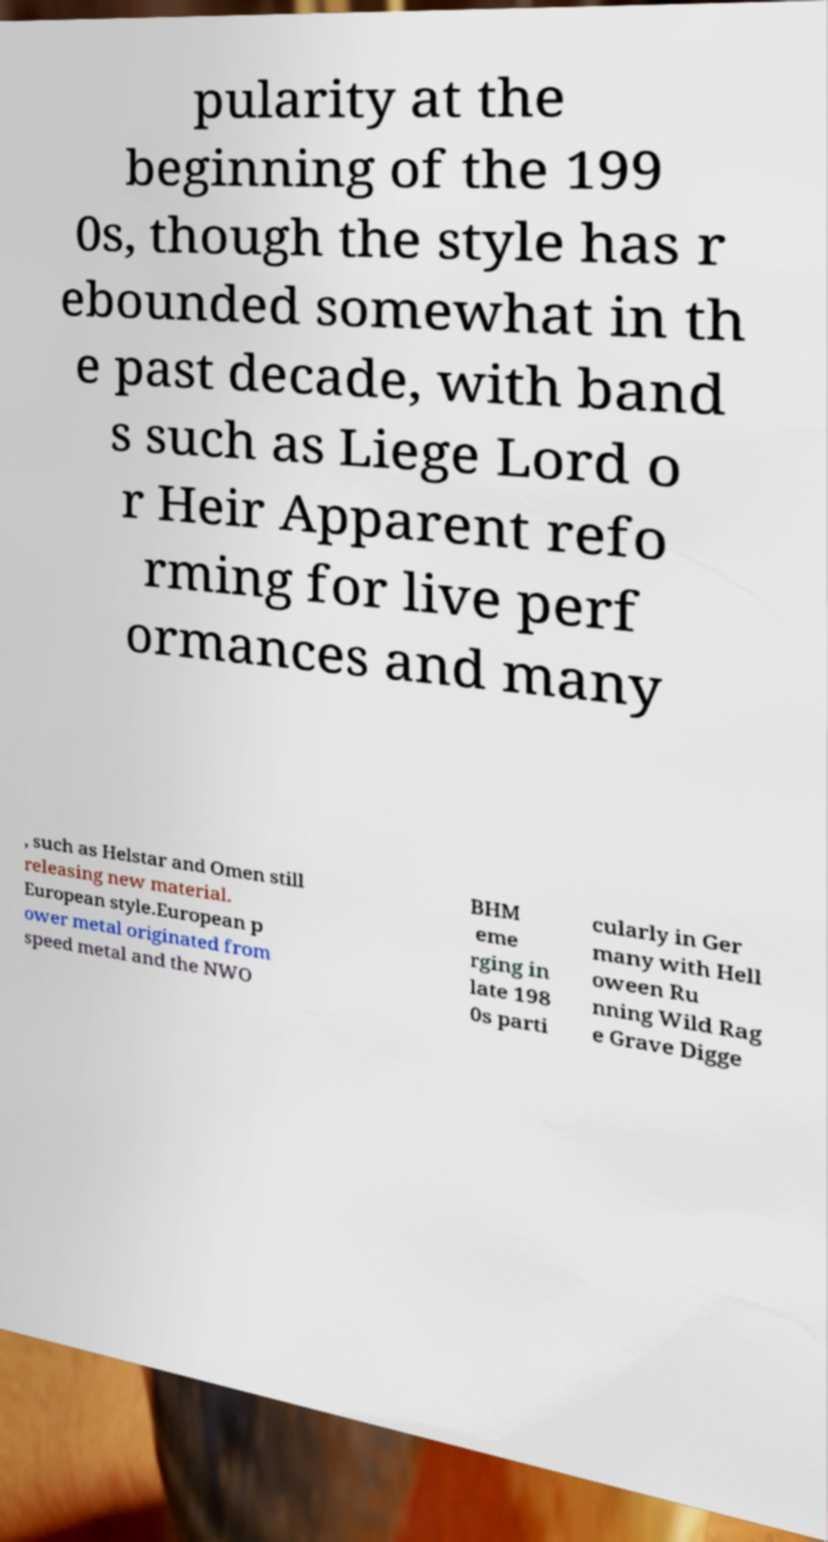Could you assist in decoding the text presented in this image and type it out clearly? pularity at the beginning of the 199 0s, though the style has r ebounded somewhat in th e past decade, with band s such as Liege Lord o r Heir Apparent refo rming for live perf ormances and many , such as Helstar and Omen still releasing new material. European style.European p ower metal originated from speed metal and the NWO BHM eme rging in late 198 0s parti cularly in Ger many with Hell oween Ru nning Wild Rag e Grave Digge 